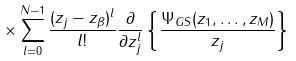Convert formula to latex. <formula><loc_0><loc_0><loc_500><loc_500>\times \sum _ { l = 0 } ^ { N - 1 } \frac { ( z _ { j } - z _ { \beta } ) ^ { l } } { l ! } \frac { \partial } { \partial z _ { j } ^ { l } } \left \{ \frac { \Psi _ { G S } ( z _ { 1 } , \dots , z _ { M } ) } { z _ { j } } \right \}</formula> 